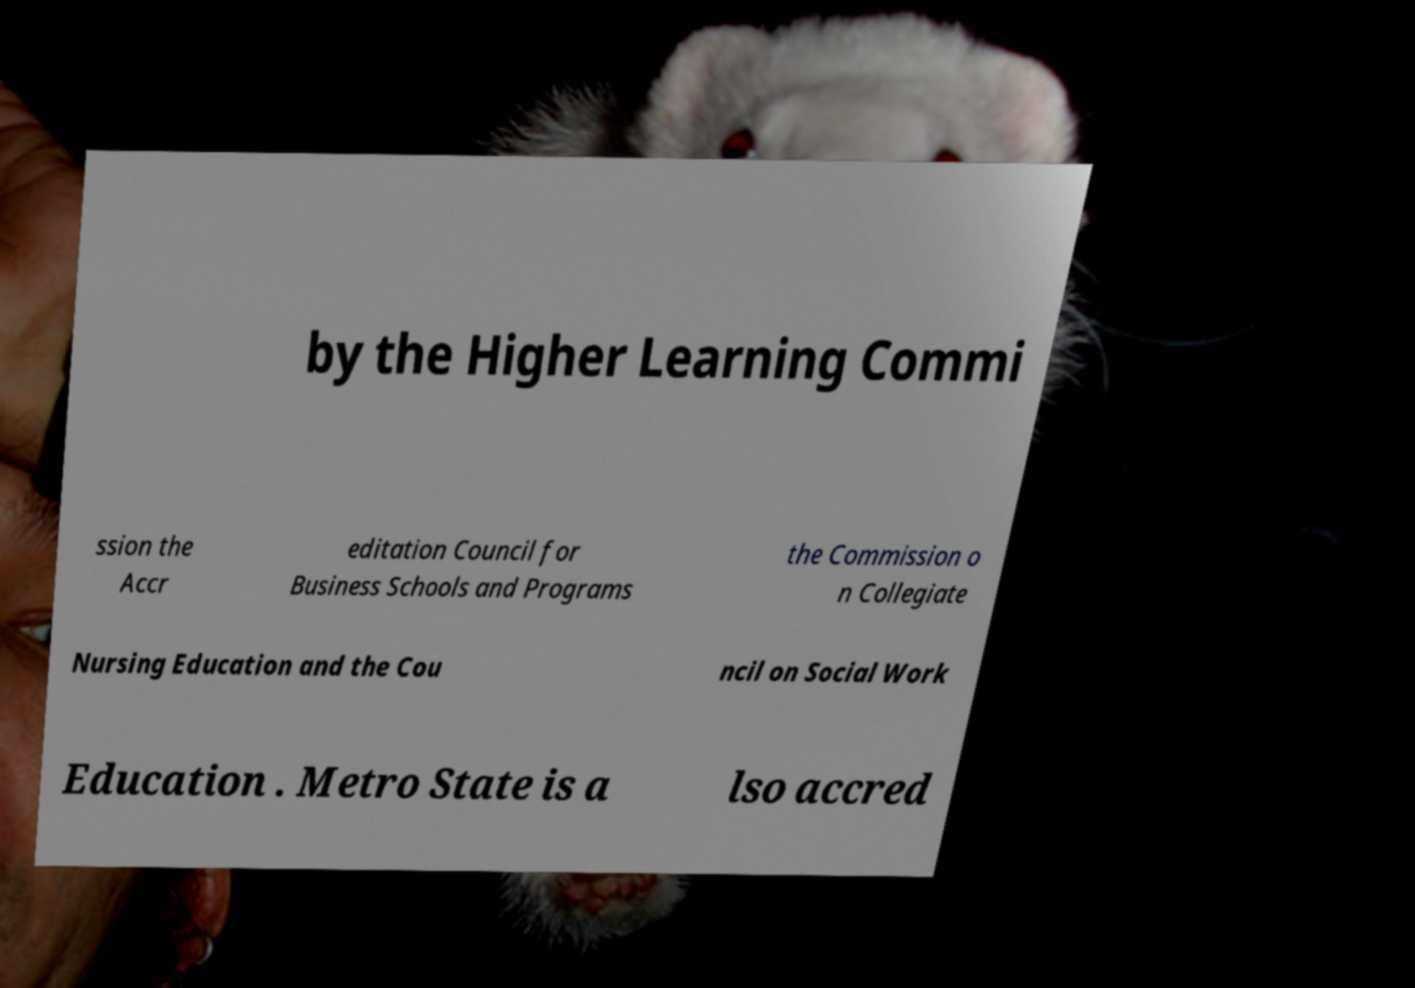Please read and relay the text visible in this image. What does it say? by the Higher Learning Commi ssion the Accr editation Council for Business Schools and Programs the Commission o n Collegiate Nursing Education and the Cou ncil on Social Work Education . Metro State is a lso accred 